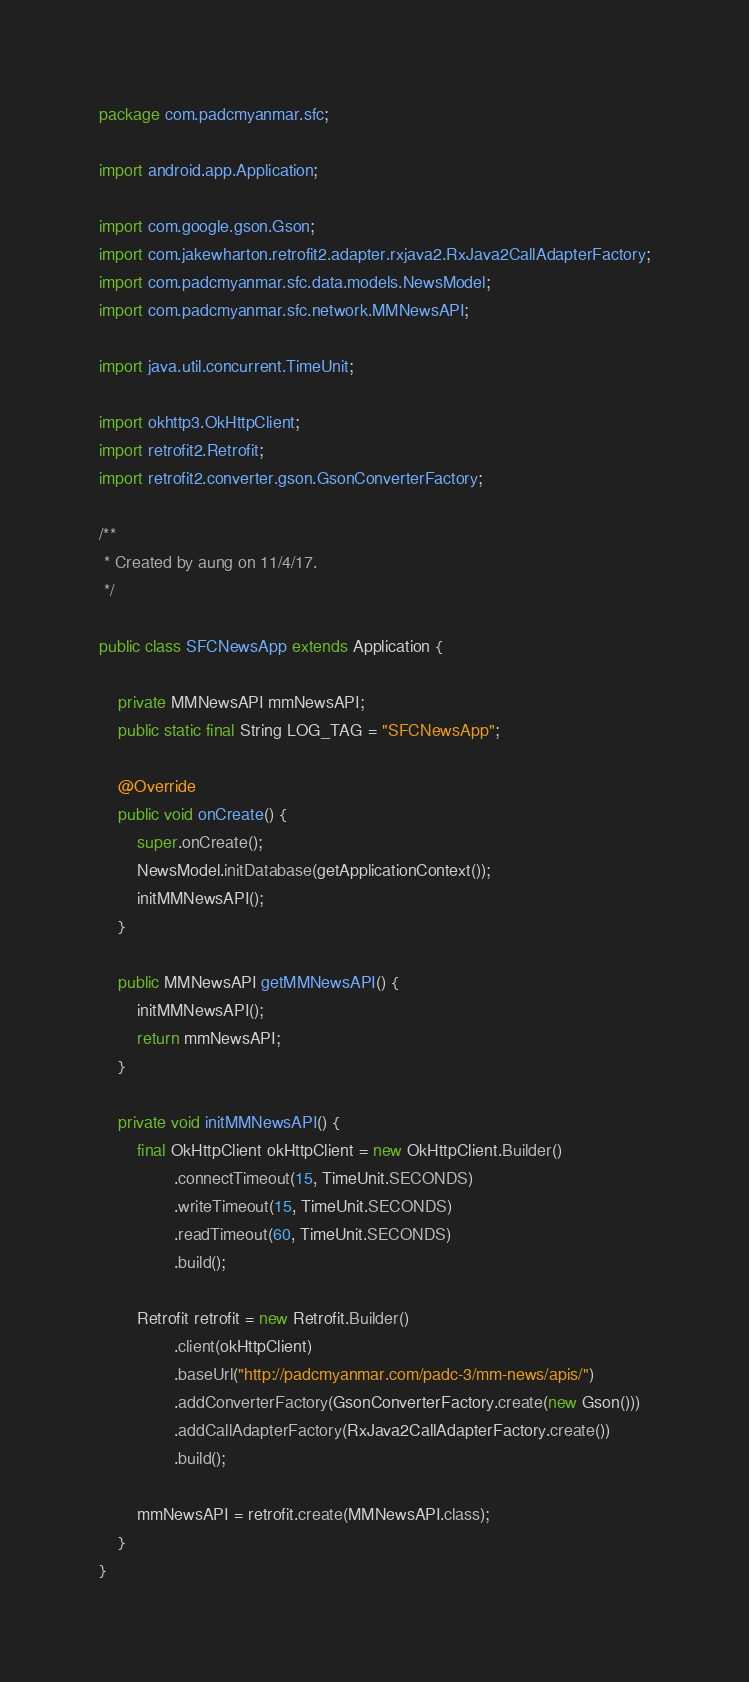<code> <loc_0><loc_0><loc_500><loc_500><_Java_>package com.padcmyanmar.sfc;

import android.app.Application;

import com.google.gson.Gson;
import com.jakewharton.retrofit2.adapter.rxjava2.RxJava2CallAdapterFactory;
import com.padcmyanmar.sfc.data.models.NewsModel;
import com.padcmyanmar.sfc.network.MMNewsAPI;

import java.util.concurrent.TimeUnit;

import okhttp3.OkHttpClient;
import retrofit2.Retrofit;
import retrofit2.converter.gson.GsonConverterFactory;

/**
 * Created by aung on 11/4/17.
 */

public class SFCNewsApp extends Application {

    private MMNewsAPI mmNewsAPI;
    public static final String LOG_TAG = "SFCNewsApp";

    @Override
    public void onCreate() {
        super.onCreate();
        NewsModel.initDatabase(getApplicationContext());
        initMMNewsAPI();
    }

    public MMNewsAPI getMMNewsAPI() {
        initMMNewsAPI();
        return mmNewsAPI;
    }

    private void initMMNewsAPI() {
        final OkHttpClient okHttpClient = new OkHttpClient.Builder()
                .connectTimeout(15, TimeUnit.SECONDS)
                .writeTimeout(15, TimeUnit.SECONDS)
                .readTimeout(60, TimeUnit.SECONDS)
                .build();

        Retrofit retrofit = new Retrofit.Builder()
                .client(okHttpClient)
                .baseUrl("http://padcmyanmar.com/padc-3/mm-news/apis/")
                .addConverterFactory(GsonConverterFactory.create(new Gson()))
                .addCallAdapterFactory(RxJava2CallAdapterFactory.create())
                .build();

        mmNewsAPI = retrofit.create(MMNewsAPI.class);
    }
}
</code> 